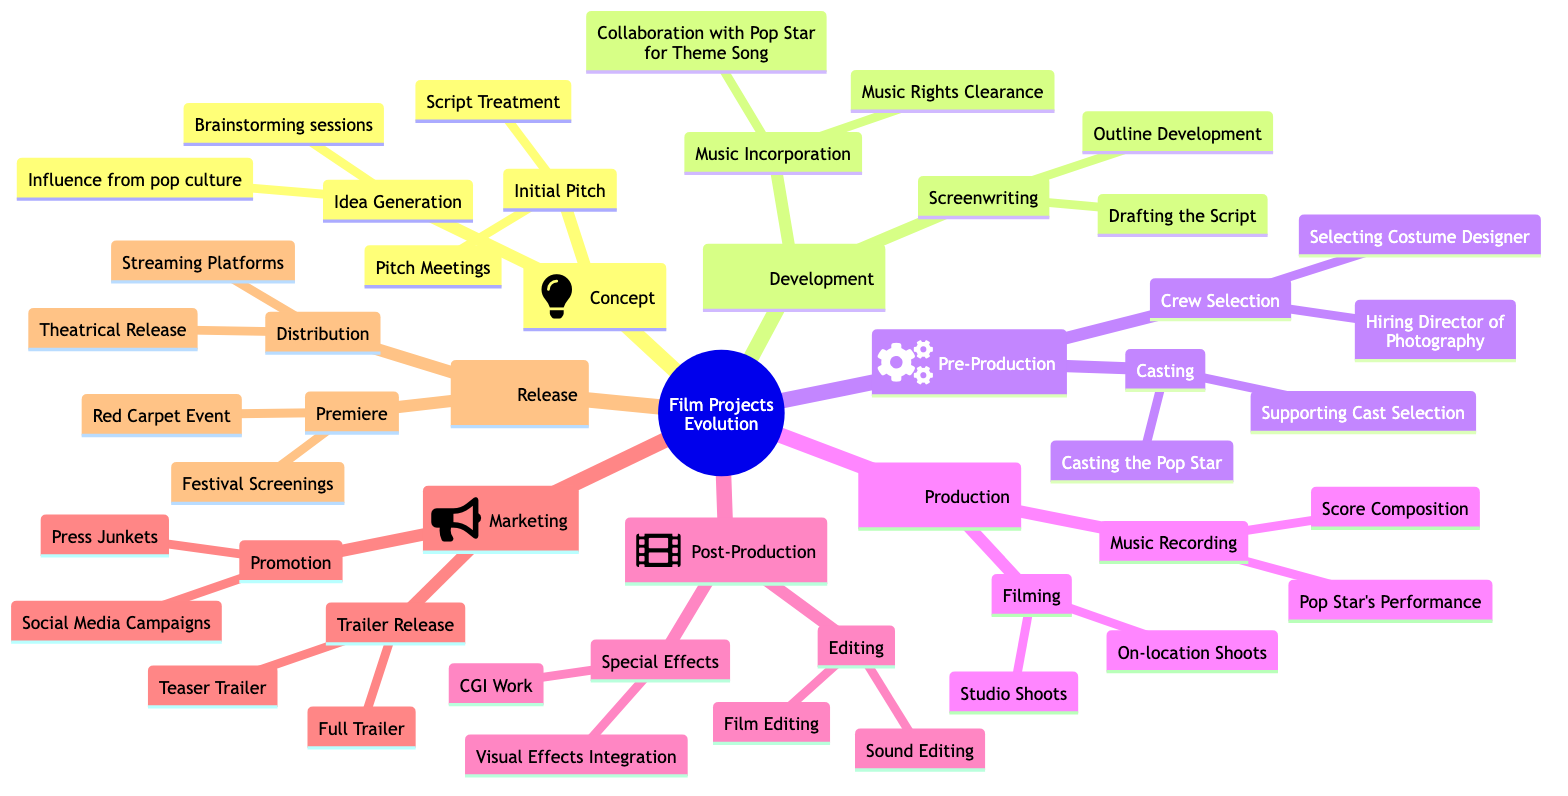What are the two main phases in the film project evolution? The diagram lists the phases under the root node "Film Projects Evolution" and identifies them as "Concept" and "Development." These are the first two phases that initiate the process of film project evolution.
Answer: Concept, Development How many activities are involved in the "Concept" phase? Under the "Concept" phase, there are two main activities: "Idea Generation" and "Initial Pitch." Each of these activities has two corresponding tasks, totaling four tasks in this phase.
Answer: 4 What is the primary activity associated with "Development"? Looking at the "Development" phase, the primary activities noted are "Screenwriting" and "Music Incorporation." The second activity, "Music Incorporation," highlights collaboration with the pop star for the theme song.
Answer: Music Incorporation What activity follows "Pre-Production"? The structure of the diagram indicates that "Production" comes directly after "Pre-Production." The flow from one node to the next defines the sequential nature of the film project evolution stages.
Answer: Production Which activity includes collaboration with the pop star? Within the "Development" phase, "Music Incorporation" includes the task "Collaboration with Pop Star for Theme Song," clearly specifying the involvement of the pop star in that particular activity.
Answer: Collaboration with Pop Star for Theme Song How many types of releases are mentioned under "Release"? The "Release" phase includes two types: "Premiere" and "Distribution." Under "Distribution," further details clarify it consists of "Theatrical Release" and "Streaming Platforms," but fundamentally there are two main types of releases identified.
Answer: 2 What are the two tasks associated with casting? The "Casting" activity under "Pre-Production" includes two tasks: "Casting the Pop Star" and "Supporting Cast Selection." These tasks outline the essential roles in the casting process prior to film production.
Answer: Casting the Pop Star, Supporting Cast Selection Which phase includes both filming and music recording? The "Production" phase encompasses both "Filming" and "Music Recording." This indicates that during this stage of development, visual and auditory content is created simultaneously.
Answer: Production What is the first task listed in "Post-Production"? In the "Post-Production" phase, the first task indicated is "Editing." This phase follows the production and focuses on finalizing the visual and audio elements of the film.
Answer: Editing 